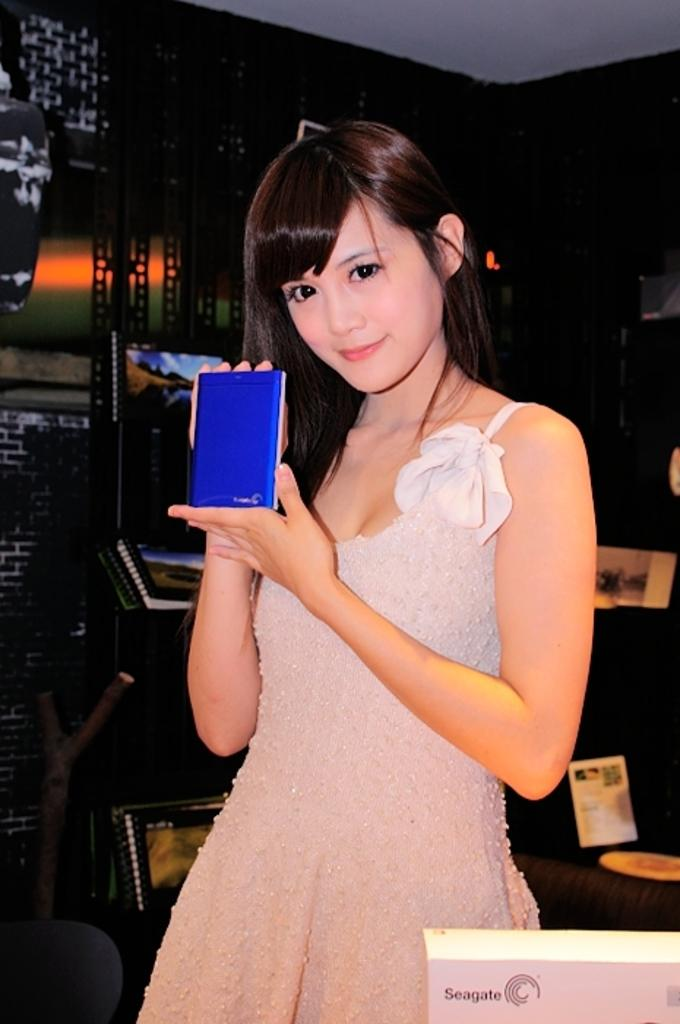Who is the main subject in the image? There is a girl in the image. What is the girl's expression in the image? The girl is smiling in the image. What is the girl holding in her hands? The girl is holding a blue object in her hands. What can be seen in the background of the image? There are albums visible in the background of the image. What type of polish is the girl applying to her nails in the image? There is no indication in the image that the girl is applying polish to her nails, as she is holding a blue object and not a nail polish bottle. 